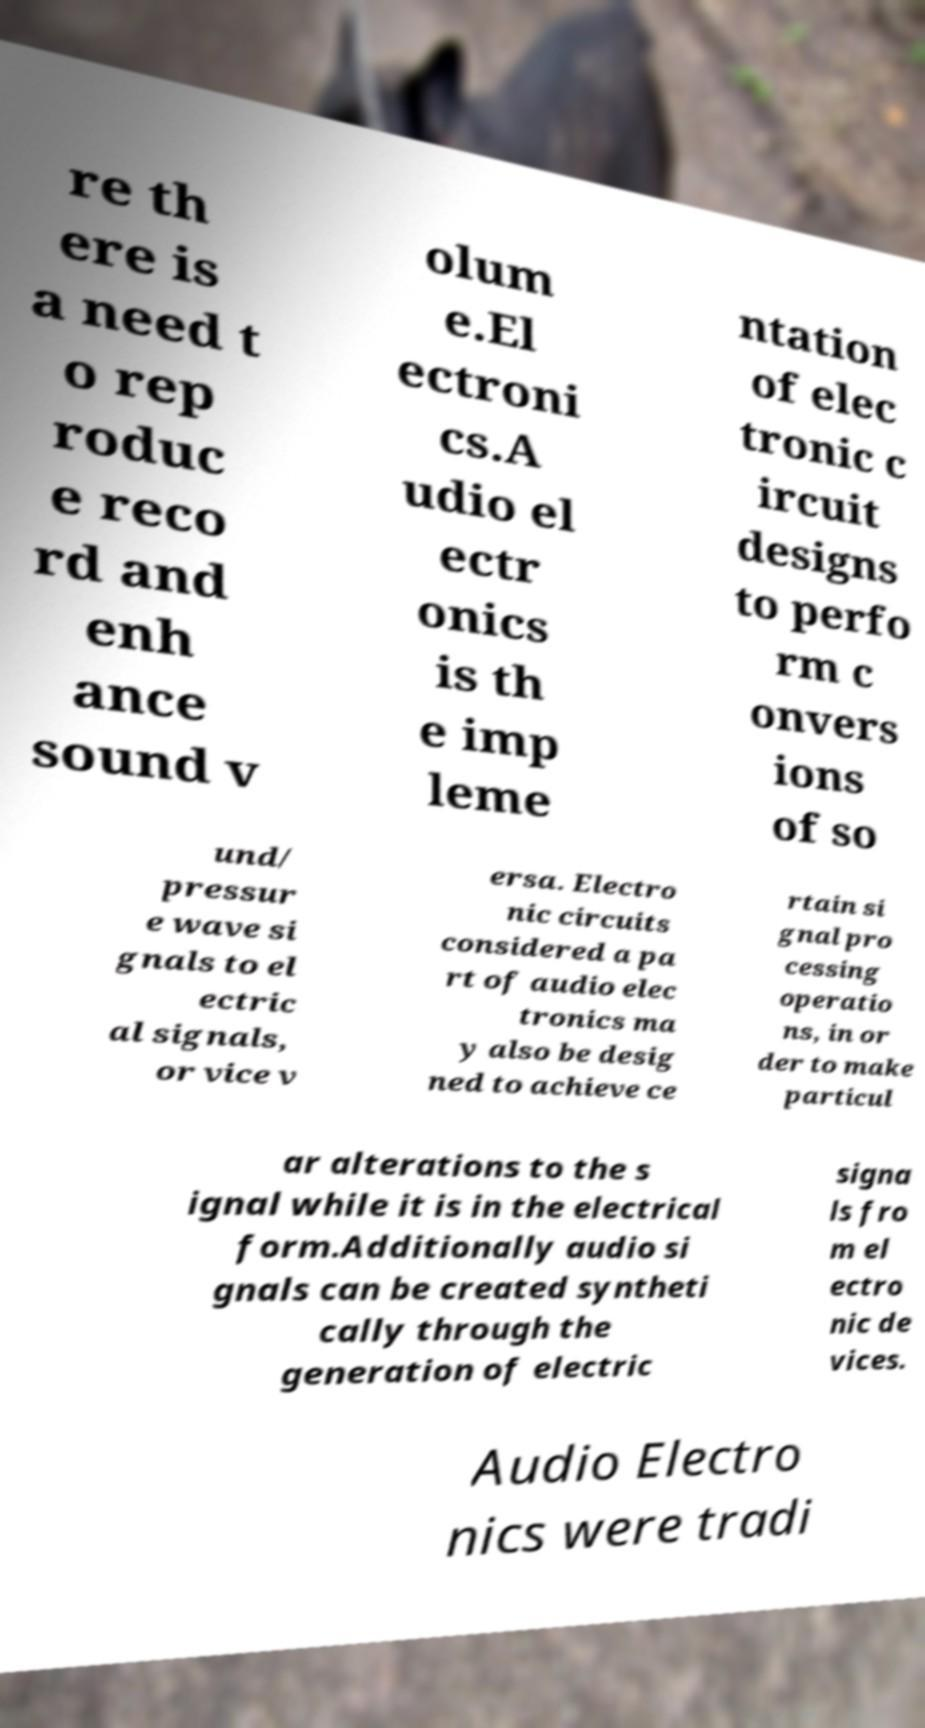I need the written content from this picture converted into text. Can you do that? re th ere is a need t o rep roduc e reco rd and enh ance sound v olum e.El ectroni cs.A udio el ectr onics is th e imp leme ntation of elec tronic c ircuit designs to perfo rm c onvers ions of so und/ pressur e wave si gnals to el ectric al signals, or vice v ersa. Electro nic circuits considered a pa rt of audio elec tronics ma y also be desig ned to achieve ce rtain si gnal pro cessing operatio ns, in or der to make particul ar alterations to the s ignal while it is in the electrical form.Additionally audio si gnals can be created syntheti cally through the generation of electric signa ls fro m el ectro nic de vices. Audio Electro nics were tradi 